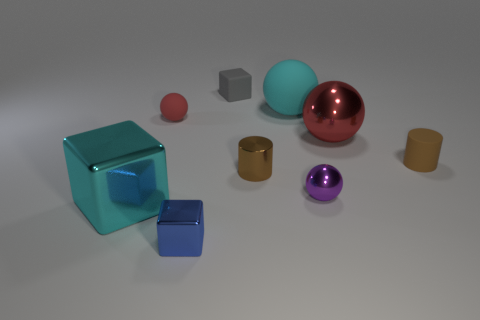There is a red object to the left of the block on the right side of the blue shiny block; is there a blue metallic object in front of it?
Offer a very short reply. Yes. What is the big cube made of?
Offer a very short reply. Metal. What number of other objects are the same shape as the big red metal thing?
Ensure brevity in your answer.  3. Do the blue thing and the tiny purple thing have the same shape?
Your response must be concise. No. What number of things are either rubber spheres that are to the left of the big matte ball or small cubes that are behind the purple metal ball?
Ensure brevity in your answer.  2. What number of things are either gray metal blocks or big cyan objects?
Offer a very short reply. 2. How many tiny rubber cylinders are in front of the cyan object in front of the tiny brown rubber thing?
Provide a short and direct response. 0. What number of other things are there of the same size as the matte block?
Give a very brief answer. 5. There is a thing that is the same color as the large matte ball; what is its size?
Your answer should be compact. Large. Do the tiny metallic object to the right of the cyan sphere and the gray rubber object have the same shape?
Your answer should be very brief. No. 